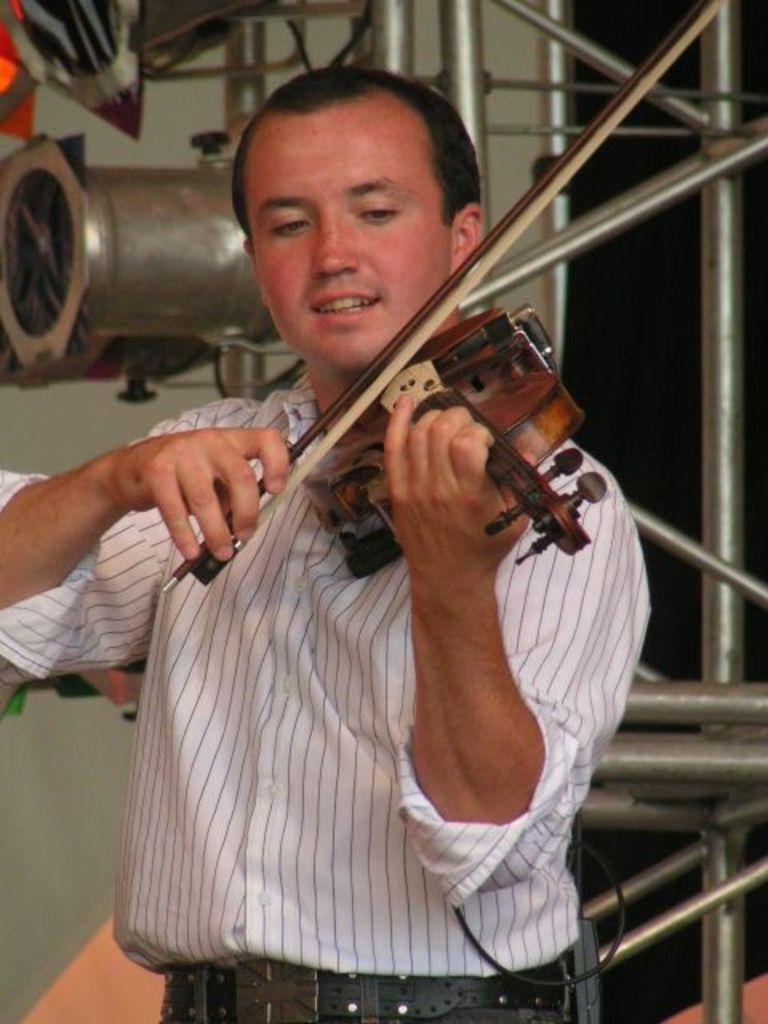What is the person in the image doing? The person is standing and playing the violin. What expression does the person have? The person is smiling. What can be seen in the background of the image? There is a wall and rods in the background of the image. What type of oatmeal is the person eating while playing the violin in the image? There is no oatmeal present in the image, and the person is not eating anything while playing the violin. What type of change or transformation is happening to the person in the image? There is no change or transformation happening to the person in the image; they are simply standing and playing the violin. 